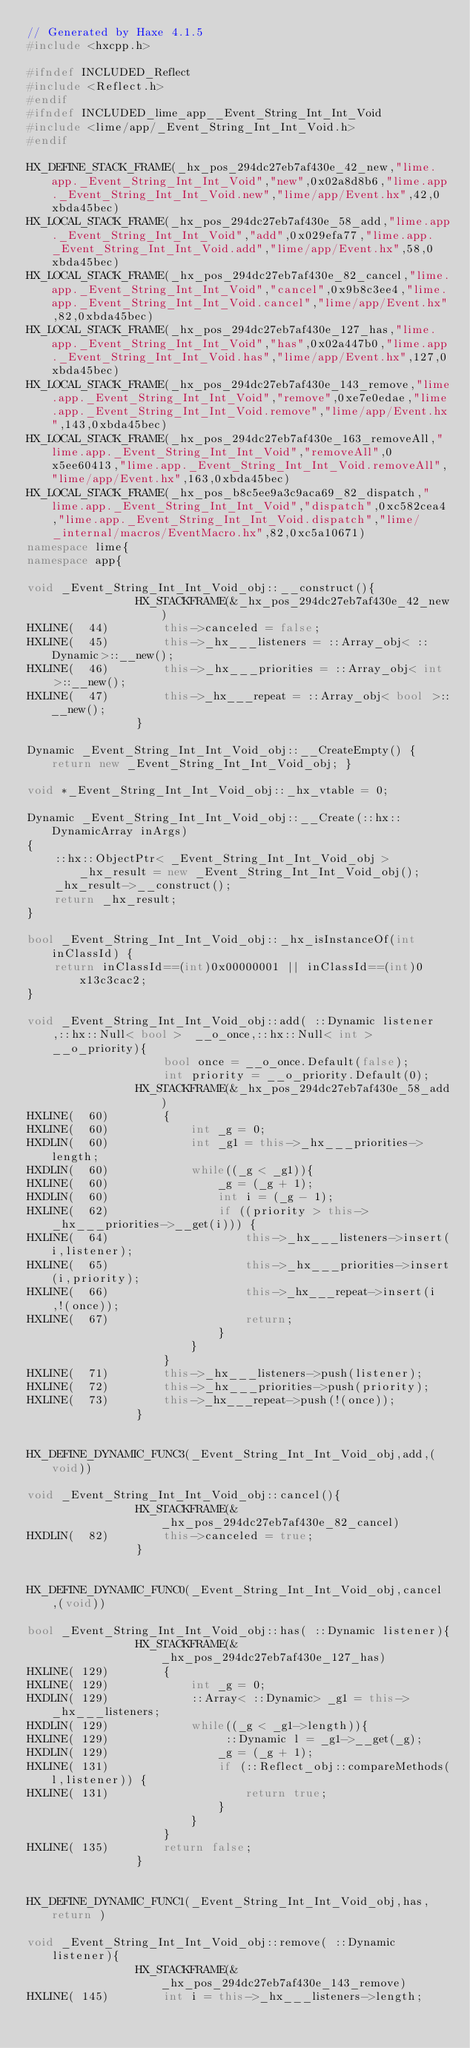Convert code to text. <code><loc_0><loc_0><loc_500><loc_500><_C++_>// Generated by Haxe 4.1.5
#include <hxcpp.h>

#ifndef INCLUDED_Reflect
#include <Reflect.h>
#endif
#ifndef INCLUDED_lime_app__Event_String_Int_Int_Void
#include <lime/app/_Event_String_Int_Int_Void.h>
#endif

HX_DEFINE_STACK_FRAME(_hx_pos_294dc27eb7af430e_42_new,"lime.app._Event_String_Int_Int_Void","new",0x02a8d8b6,"lime.app._Event_String_Int_Int_Void.new","lime/app/Event.hx",42,0xbda45bec)
HX_LOCAL_STACK_FRAME(_hx_pos_294dc27eb7af430e_58_add,"lime.app._Event_String_Int_Int_Void","add",0x029efa77,"lime.app._Event_String_Int_Int_Void.add","lime/app/Event.hx",58,0xbda45bec)
HX_LOCAL_STACK_FRAME(_hx_pos_294dc27eb7af430e_82_cancel,"lime.app._Event_String_Int_Int_Void","cancel",0x9b8c3ee4,"lime.app._Event_String_Int_Int_Void.cancel","lime/app/Event.hx",82,0xbda45bec)
HX_LOCAL_STACK_FRAME(_hx_pos_294dc27eb7af430e_127_has,"lime.app._Event_String_Int_Int_Void","has",0x02a447b0,"lime.app._Event_String_Int_Int_Void.has","lime/app/Event.hx",127,0xbda45bec)
HX_LOCAL_STACK_FRAME(_hx_pos_294dc27eb7af430e_143_remove,"lime.app._Event_String_Int_Int_Void","remove",0xe7e0edae,"lime.app._Event_String_Int_Int_Void.remove","lime/app/Event.hx",143,0xbda45bec)
HX_LOCAL_STACK_FRAME(_hx_pos_294dc27eb7af430e_163_removeAll,"lime.app._Event_String_Int_Int_Void","removeAll",0x5ee60413,"lime.app._Event_String_Int_Int_Void.removeAll","lime/app/Event.hx",163,0xbda45bec)
HX_LOCAL_STACK_FRAME(_hx_pos_b8c5ee9a3c9aca69_82_dispatch,"lime.app._Event_String_Int_Int_Void","dispatch",0xc582cea4,"lime.app._Event_String_Int_Int_Void.dispatch","lime/_internal/macros/EventMacro.hx",82,0xc5a10671)
namespace lime{
namespace app{

void _Event_String_Int_Int_Void_obj::__construct(){
            	HX_STACKFRAME(&_hx_pos_294dc27eb7af430e_42_new)
HXLINE(  44)		this->canceled = false;
HXLINE(  45)		this->_hx___listeners = ::Array_obj< ::Dynamic>::__new();
HXLINE(  46)		this->_hx___priorities = ::Array_obj< int >::__new();
HXLINE(  47)		this->_hx___repeat = ::Array_obj< bool >::__new();
            	}

Dynamic _Event_String_Int_Int_Void_obj::__CreateEmpty() { return new _Event_String_Int_Int_Void_obj; }

void *_Event_String_Int_Int_Void_obj::_hx_vtable = 0;

Dynamic _Event_String_Int_Int_Void_obj::__Create(::hx::DynamicArray inArgs)
{
	::hx::ObjectPtr< _Event_String_Int_Int_Void_obj > _hx_result = new _Event_String_Int_Int_Void_obj();
	_hx_result->__construct();
	return _hx_result;
}

bool _Event_String_Int_Int_Void_obj::_hx_isInstanceOf(int inClassId) {
	return inClassId==(int)0x00000001 || inClassId==(int)0x13c3cac2;
}

void _Event_String_Int_Int_Void_obj::add( ::Dynamic listener,::hx::Null< bool >  __o_once,::hx::Null< int >  __o_priority){
            		bool once = __o_once.Default(false);
            		int priority = __o_priority.Default(0);
            	HX_STACKFRAME(&_hx_pos_294dc27eb7af430e_58_add)
HXLINE(  60)		{
HXLINE(  60)			int _g = 0;
HXDLIN(  60)			int _g1 = this->_hx___priorities->length;
HXDLIN(  60)			while((_g < _g1)){
HXLINE(  60)				_g = (_g + 1);
HXDLIN(  60)				int i = (_g - 1);
HXLINE(  62)				if ((priority > this->_hx___priorities->__get(i))) {
HXLINE(  64)					this->_hx___listeners->insert(i,listener);
HXLINE(  65)					this->_hx___priorities->insert(i,priority);
HXLINE(  66)					this->_hx___repeat->insert(i,!(once));
HXLINE(  67)					return;
            				}
            			}
            		}
HXLINE(  71)		this->_hx___listeners->push(listener);
HXLINE(  72)		this->_hx___priorities->push(priority);
HXLINE(  73)		this->_hx___repeat->push(!(once));
            	}


HX_DEFINE_DYNAMIC_FUNC3(_Event_String_Int_Int_Void_obj,add,(void))

void _Event_String_Int_Int_Void_obj::cancel(){
            	HX_STACKFRAME(&_hx_pos_294dc27eb7af430e_82_cancel)
HXDLIN(  82)		this->canceled = true;
            	}


HX_DEFINE_DYNAMIC_FUNC0(_Event_String_Int_Int_Void_obj,cancel,(void))

bool _Event_String_Int_Int_Void_obj::has( ::Dynamic listener){
            	HX_STACKFRAME(&_hx_pos_294dc27eb7af430e_127_has)
HXLINE( 129)		{
HXLINE( 129)			int _g = 0;
HXDLIN( 129)			::Array< ::Dynamic> _g1 = this->_hx___listeners;
HXDLIN( 129)			while((_g < _g1->length)){
HXLINE( 129)				 ::Dynamic l = _g1->__get(_g);
HXDLIN( 129)				_g = (_g + 1);
HXLINE( 131)				if (::Reflect_obj::compareMethods(l,listener)) {
HXLINE( 131)					return true;
            				}
            			}
            		}
HXLINE( 135)		return false;
            	}


HX_DEFINE_DYNAMIC_FUNC1(_Event_String_Int_Int_Void_obj,has,return )

void _Event_String_Int_Int_Void_obj::remove( ::Dynamic listener){
            	HX_STACKFRAME(&_hx_pos_294dc27eb7af430e_143_remove)
HXLINE( 145)		int i = this->_hx___listeners->length;</code> 